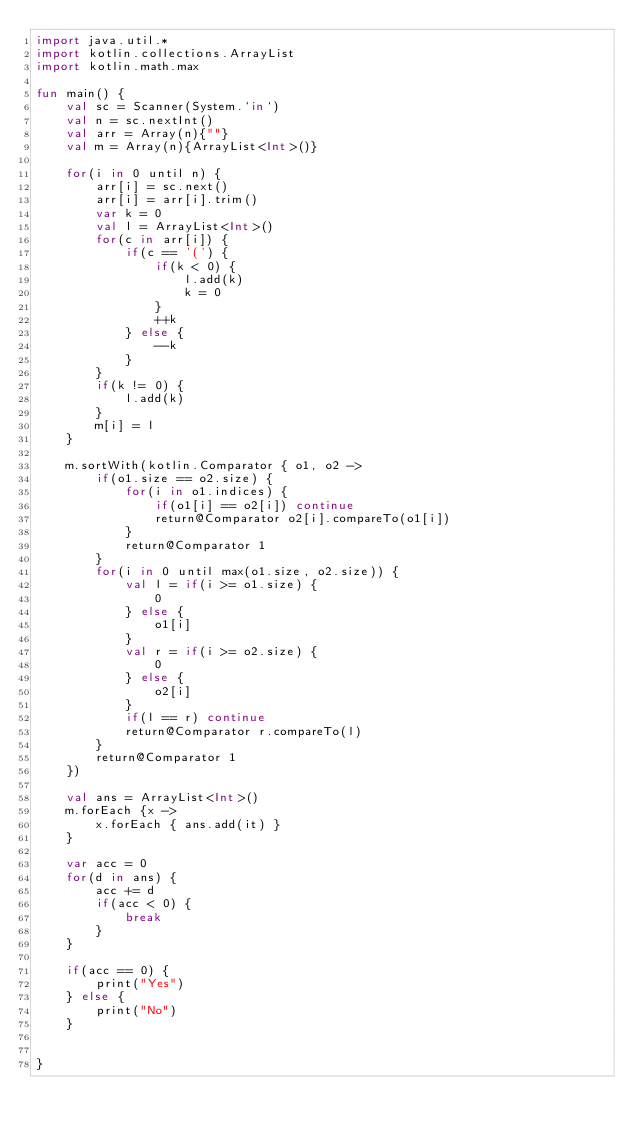<code> <loc_0><loc_0><loc_500><loc_500><_Kotlin_>import java.util.*
import kotlin.collections.ArrayList
import kotlin.math.max

fun main() {
    val sc = Scanner(System.`in`)
    val n = sc.nextInt()
    val arr = Array(n){""}
    val m = Array(n){ArrayList<Int>()}

    for(i in 0 until n) {
        arr[i] = sc.next()
        arr[i] = arr[i].trim()
        var k = 0
        val l = ArrayList<Int>()
        for(c in arr[i]) {
            if(c == '(') {
                if(k < 0) {
                    l.add(k)
                    k = 0
                }
                ++k
            } else {
                --k
            }
        }
        if(k != 0) {
            l.add(k)
        }
        m[i] = l
    }

    m.sortWith(kotlin.Comparator { o1, o2 ->
        if(o1.size == o2.size) {
            for(i in o1.indices) {
                if(o1[i] == o2[i]) continue
                return@Comparator o2[i].compareTo(o1[i])
            }
            return@Comparator 1
        }
        for(i in 0 until max(o1.size, o2.size)) {
            val l = if(i >= o1.size) {
                0
            } else {
                o1[i]
            }
            val r = if(i >= o2.size) {
                0
            } else {
                o2[i]
            }
            if(l == r) continue
            return@Comparator r.compareTo(l)
        }
        return@Comparator 1
    })

    val ans = ArrayList<Int>()
    m.forEach {x ->
        x.forEach { ans.add(it) }
    }

    var acc = 0
    for(d in ans) {
        acc += d
        if(acc < 0) {
            break
        }
    }

    if(acc == 0) {
        print("Yes")
    } else {
        print("No")
    }


}</code> 